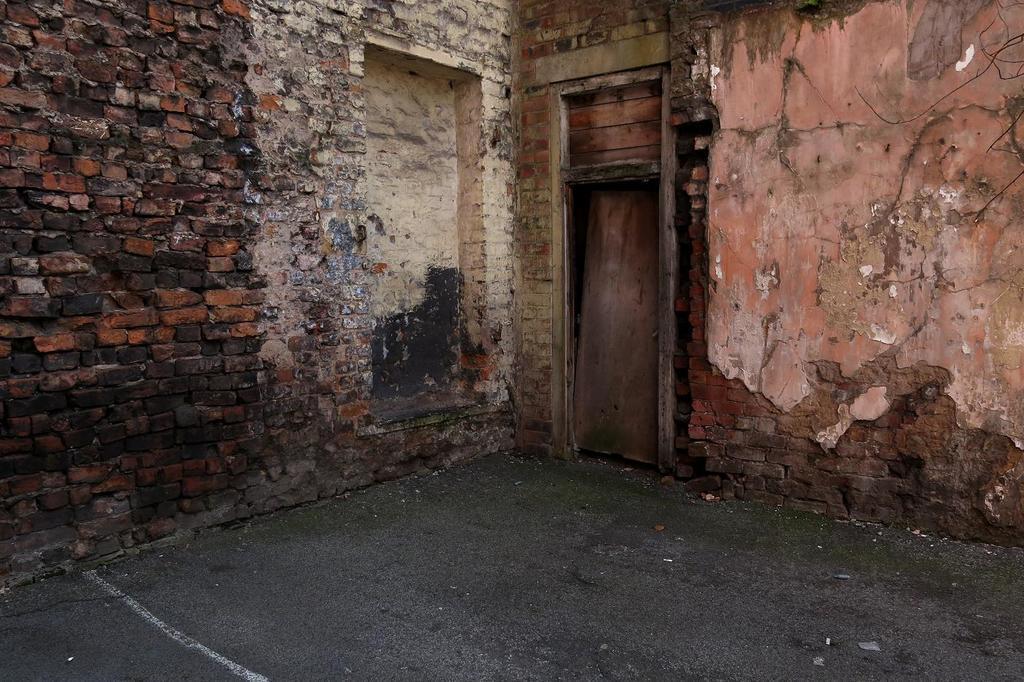In one or two sentences, can you explain what this image depicts? In this image we can see brick wall and wooden door. 